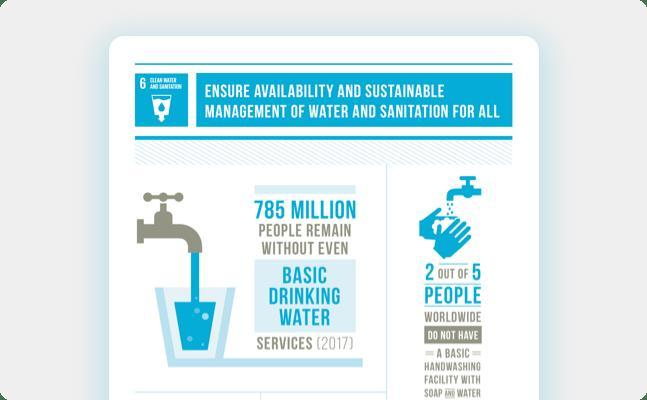How many people do not have basic drinking water services?
Answer the question with a short phrase. 785 million What is the ratio of people without access to proper handwashing facility? 2 out of 5 What facility does about 40% of people worldwide not have? A basic handwashing facility 